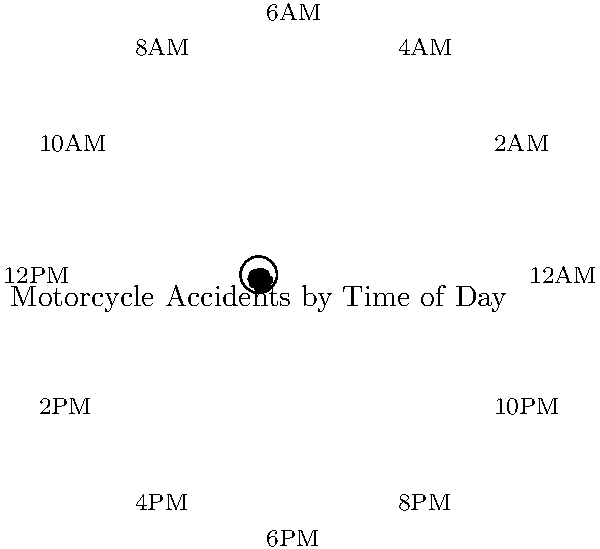Based on the circular histogram showing the distribution of motorcycle accidents by time of day, which time period appears to have the highest number of accidents? To determine the time period with the highest number of accidents, we need to analyze the circular histogram:

1. The circular histogram represents a 24-hour cycle, divided into 12 two-hour intervals.
2. Each bar in the histogram represents the number of accidents for that time period.
3. The length of each bar is proportional to the number of accidents.
4. We need to identify the longest bar in the histogram.

Examining the histogram:
- The shortest bars are between 4AM and 10AM, indicating fewer accidents during these hours.
- The bars start to increase in length from 12PM onwards.
- The longest bar appears to be at the 6PM-8PM interval.
- The bar lengths decrease slightly after 8PM but remain relatively high until 12AM.

Therefore, based on the visual representation, the time period with the highest number of accidents appears to be between 6PM and 8PM.
Answer: 6PM-8PM 